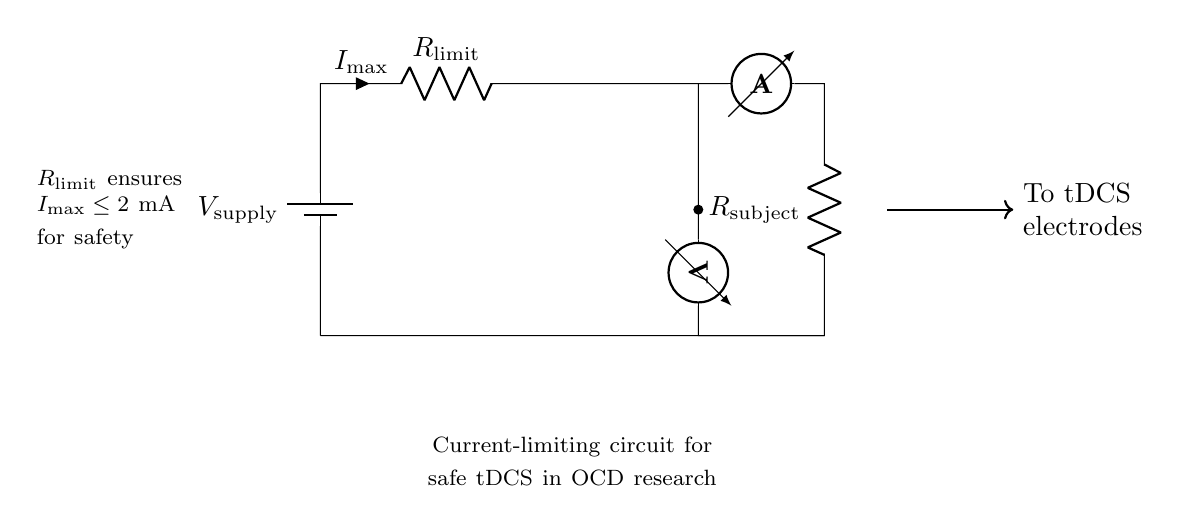What is the maximum current allowed in this circuit? The circuit indicates that the current is limited to a maximum of 2 mA for safety, as specified next to the current-limiting resistor labeled $R_\text{limit}$.
Answer: 2 mA What type of component is $R_\text{limit}$? The component $R_\text{limit}$ is a resistor that serves to limit the current flowing through the circuit, as indicated by its label and function in the circuit diagram.
Answer: Resistor What does the voltmeter measure? The voltmeter in the circuit measures the voltage across the load represented by the resistor labeled $R_\text{subject}$, which is located further down the circuit.
Answer: Voltage across the subject What is the purpose of the ammeter in this circuit? The ammeter is placed in series to measure the current flowing through the circuit, allowing researchers to monitor the current delivered to the subject effectively.
Answer: Measure current Why is the current-limiting resistor important for tDCS? The current-limiting resistor is critical to ensure that the current does not exceed safe levels (2 mA), which is especially important when applying direct current stimulation to subjects in research to prevent harm.
Answer: Ensures safety What does the arrow pointing to the right indicate in the circuit? The arrow indicates the direction of current flow from the circuit to the electrodes used in the transcranial direct current stimulation (tDCS), ensuring the correct path for electricity.
Answer: Direction of current flow 